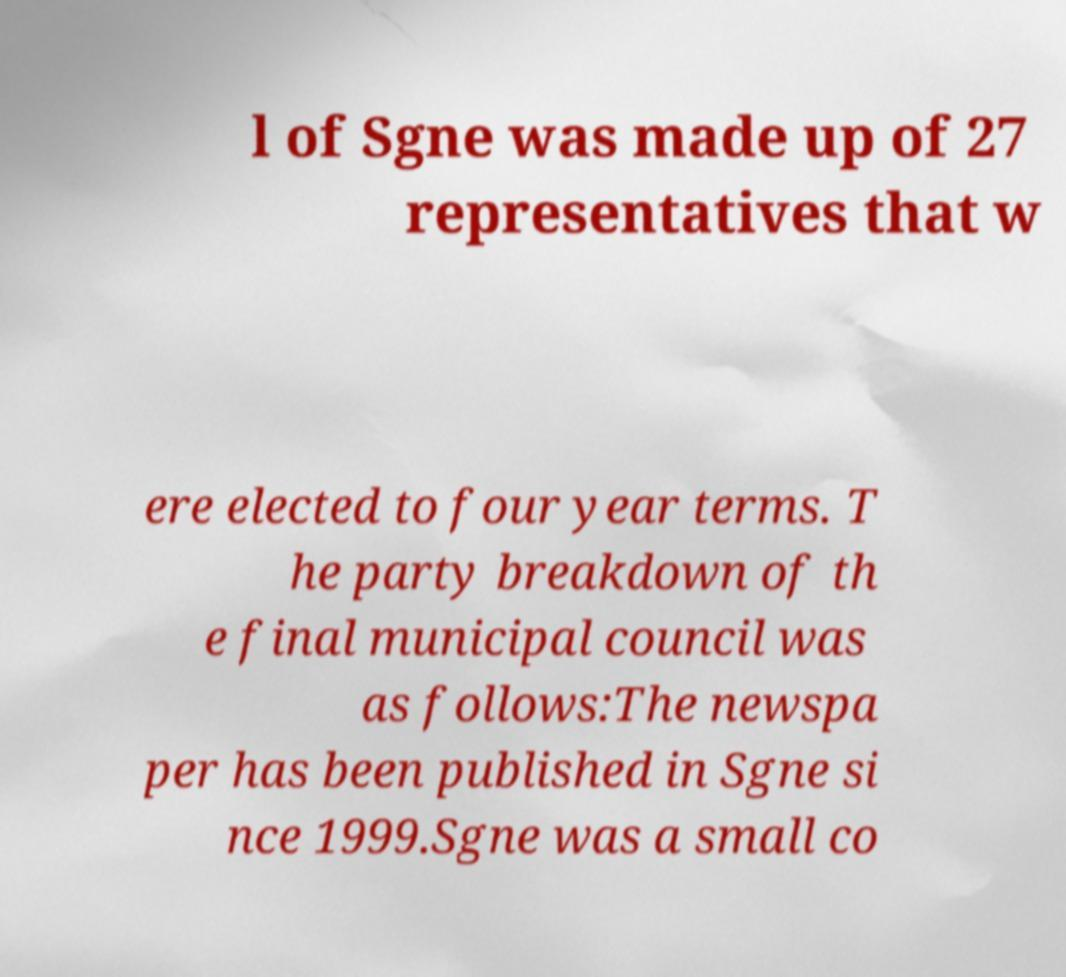Could you extract and type out the text from this image? l of Sgne was made up of 27 representatives that w ere elected to four year terms. T he party breakdown of th e final municipal council was as follows:The newspa per has been published in Sgne si nce 1999.Sgne was a small co 